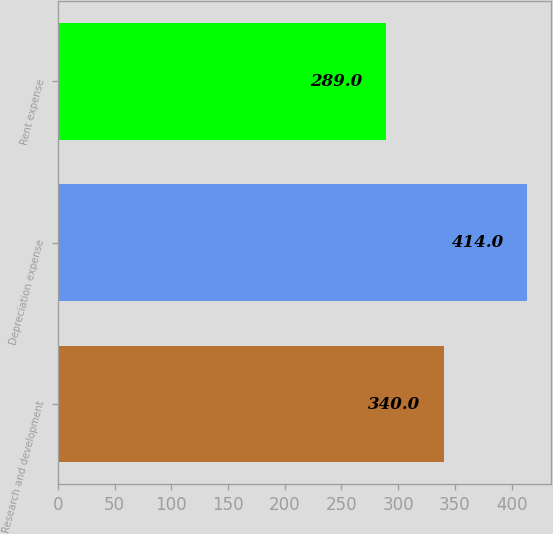Convert chart. <chart><loc_0><loc_0><loc_500><loc_500><bar_chart><fcel>Research and development<fcel>Depreciation expense<fcel>Rent expense<nl><fcel>340<fcel>414<fcel>289<nl></chart> 